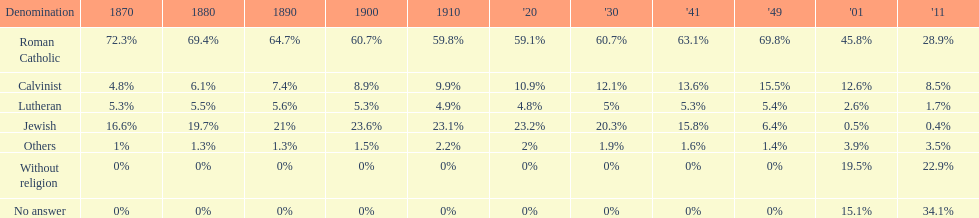What is the complete percentage of persons who recognized themselves as religious in 2011? 43%. Can you parse all the data within this table? {'header': ['Denomination', '1870', '1880', '1890', '1900', '1910', "'20", "'30", "'41", "'49", "'01", "'11"], 'rows': [['Roman Catholic', '72.3%', '69.4%', '64.7%', '60.7%', '59.8%', '59.1%', '60.7%', '63.1%', '69.8%', '45.8%', '28.9%'], ['Calvinist', '4.8%', '6.1%', '7.4%', '8.9%', '9.9%', '10.9%', '12.1%', '13.6%', '15.5%', '12.6%', '8.5%'], ['Lutheran', '5.3%', '5.5%', '5.6%', '5.3%', '4.9%', '4.8%', '5%', '5.3%', '5.4%', '2.6%', '1.7%'], ['Jewish', '16.6%', '19.7%', '21%', '23.6%', '23.1%', '23.2%', '20.3%', '15.8%', '6.4%', '0.5%', '0.4%'], ['Others', '1%', '1.3%', '1.3%', '1.5%', '2.2%', '2%', '1.9%', '1.6%', '1.4%', '3.9%', '3.5%'], ['Without religion', '0%', '0%', '0%', '0%', '0%', '0%', '0%', '0%', '0%', '19.5%', '22.9%'], ['No answer', '0%', '0%', '0%', '0%', '0%', '0%', '0%', '0%', '0%', '15.1%', '34.1%']]} 